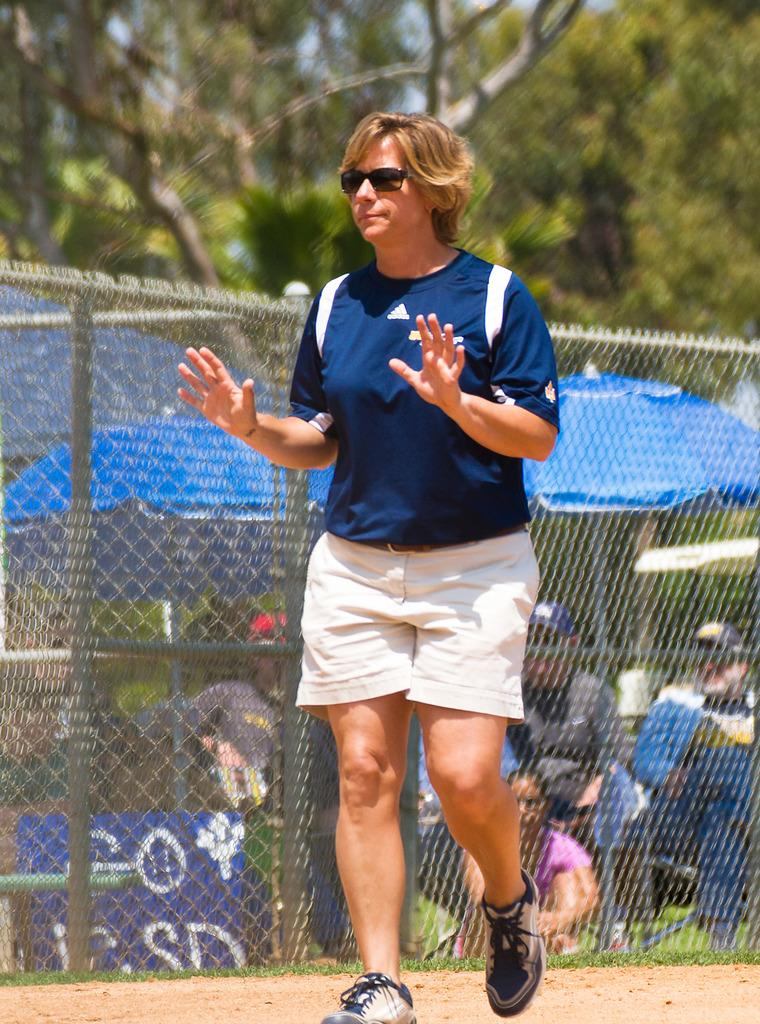Who is the main subject in the image? There is a woman in the middle of the image. What can be seen in the background of the image? Trees are visible in the background of the image. What is the woman standing near in the image? There is a fence in the image. What are the people in the image holding? Umbrellas are present in the image. What type of wool is being spun by the woman in the image? There is no wool or spinning activity present in the image. What root is growing near the fence in the image? There is no root visible in the image; only the fence and the woman are present. 